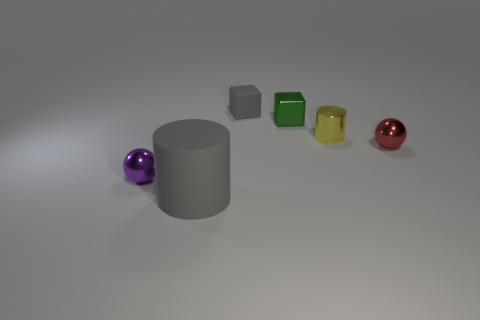There is a gray object that is the same size as the red metallic object; what shape is it?
Give a very brief answer. Cube. Is the number of small cylinders less than the number of big yellow balls?
Keep it short and to the point. No. Is there a tiny yellow cylinder that is on the right side of the cylinder right of the tiny gray block?
Offer a terse response. No. There is a tiny metal sphere that is right of the gray object in front of the tiny yellow shiny thing; are there any yellow objects that are in front of it?
Provide a succinct answer. No. There is a rubber object behind the small purple shiny thing; does it have the same shape as the rubber object in front of the small gray matte object?
Make the answer very short. No. What is the color of the tiny cube that is made of the same material as the big gray cylinder?
Offer a terse response. Gray. Are there fewer small blocks that are behind the green metal thing than tiny gray objects?
Your answer should be very brief. No. There is a gray object in front of the metallic object to the left of the cylinder that is in front of the yellow object; how big is it?
Provide a short and direct response. Large. Is the material of the cylinder that is behind the purple shiny object the same as the gray block?
Your answer should be very brief. No. What material is the block that is the same color as the big cylinder?
Your response must be concise. Rubber. 